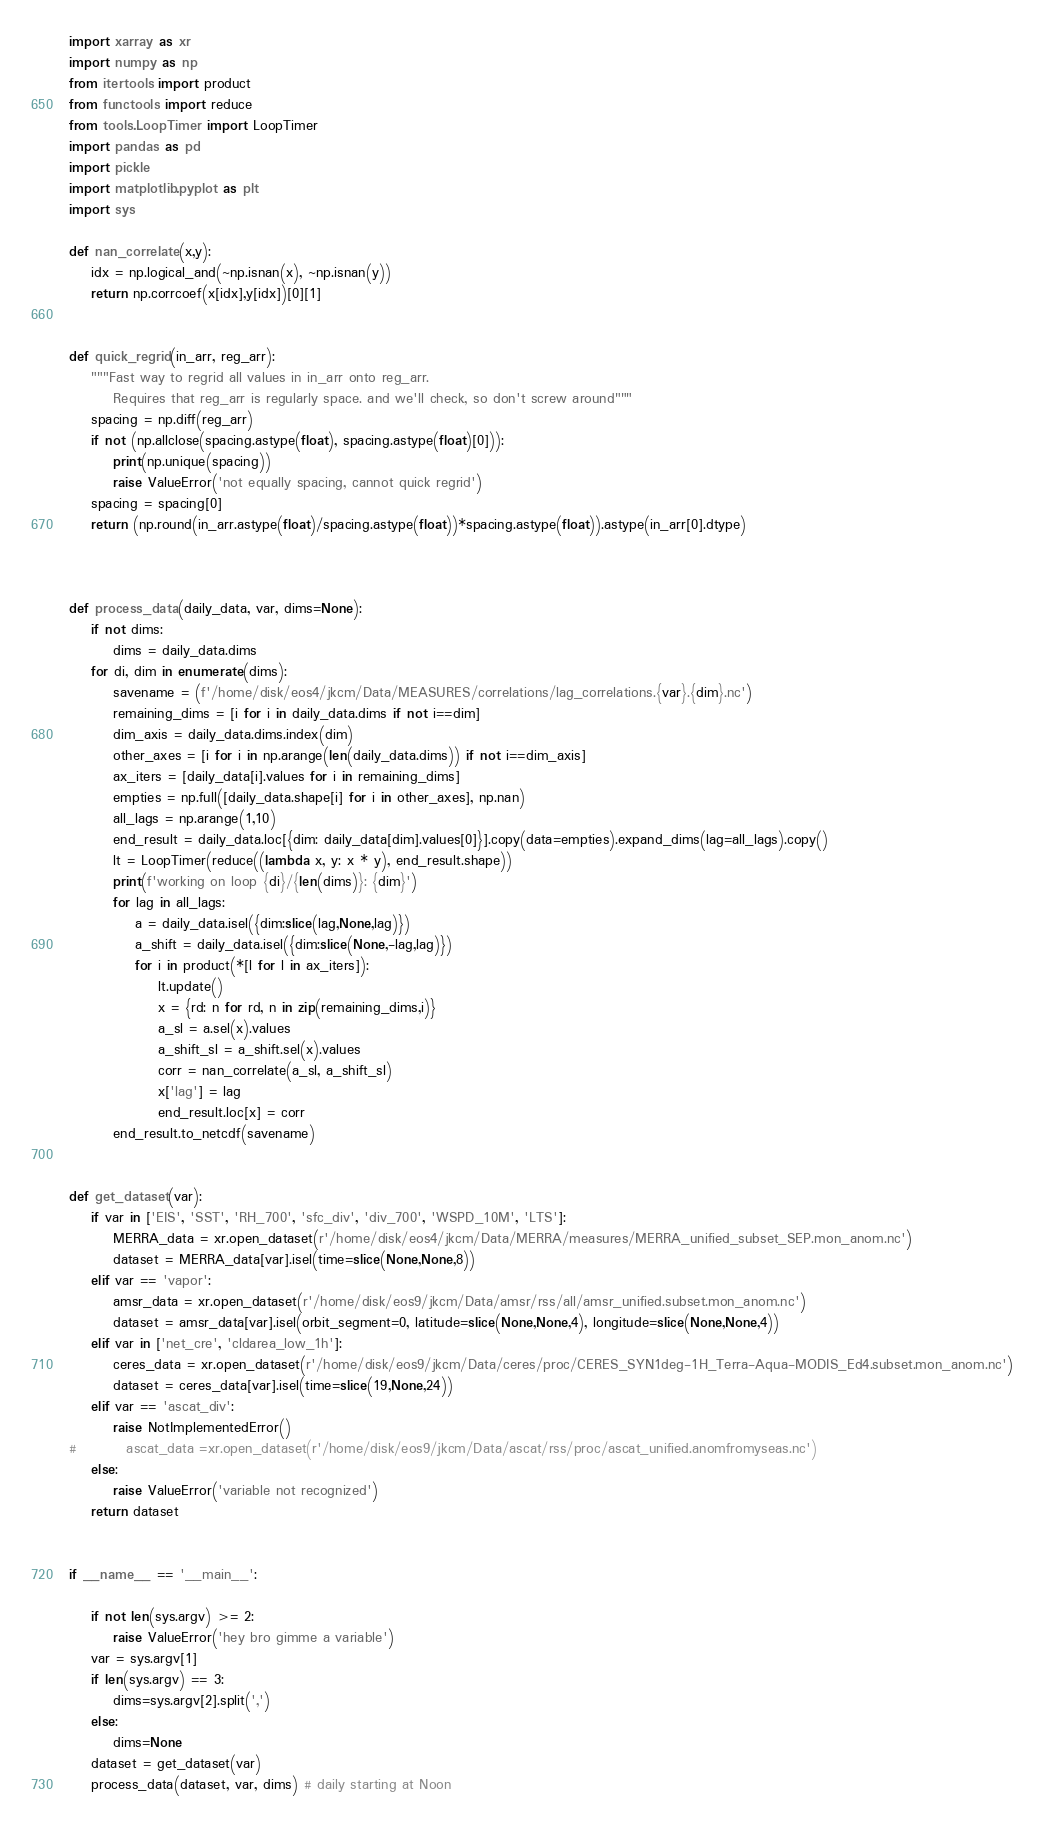<code> <loc_0><loc_0><loc_500><loc_500><_Python_>import xarray as xr
import numpy as np
from itertools import product
from functools import reduce
from tools.LoopTimer import LoopTimer
import pandas as pd
import pickle
import matplotlib.pyplot as plt
import sys

def nan_correlate(x,y):
    idx = np.logical_and(~np.isnan(x), ~np.isnan(y))
    return np.corrcoef(x[idx],y[idx])[0][1]


def quick_regrid(in_arr, reg_arr):
    """Fast way to regrid all values in in_arr onto reg_arr.
        Requires that reg_arr is regularly space. and we'll check, so don't screw around"""
    spacing = np.diff(reg_arr)
    if not (np.allclose(spacing.astype(float), spacing.astype(float)[0])):
        print(np.unique(spacing))
        raise ValueError('not equally spacing, cannot quick regrid')
    spacing = spacing[0]
    return (np.round(in_arr.astype(float)/spacing.astype(float))*spacing.astype(float)).astype(in_arr[0].dtype)
    


def process_data(daily_data, var, dims=None):
    if not dims:
        dims = daily_data.dims
    for di, dim in enumerate(dims):
        savename = (f'/home/disk/eos4/jkcm/Data/MEASURES/correlations/lag_correlations.{var}.{dim}.nc')
        remaining_dims = [i for i in daily_data.dims if not i==dim]
        dim_axis = daily_data.dims.index(dim)
        other_axes = [i for i in np.arange(len(daily_data.dims)) if not i==dim_axis]
        ax_iters = [daily_data[i].values for i in remaining_dims]
        empties = np.full([daily_data.shape[i] for i in other_axes], np.nan)
        all_lags = np.arange(1,10)
        end_result = daily_data.loc[{dim: daily_data[dim].values[0]}].copy(data=empties).expand_dims(lag=all_lags).copy()
        lt = LoopTimer(reduce((lambda x, y: x * y), end_result.shape))
        print(f'working on loop {di}/{len(dims)}: {dim}')
        for lag in all_lags:
            a = daily_data.isel({dim:slice(lag,None,lag)})
            a_shift = daily_data.isel({dim:slice(None,-lag,lag)})
            for i in product(*[l for l in ax_iters]):
                lt.update()
                x = {rd: n for rd, n in zip(remaining_dims,i)}
                a_sl = a.sel(x).values
                a_shift_sl = a_shift.sel(x).values
                corr = nan_correlate(a_sl, a_shift_sl)
                x['lag'] = lag
                end_result.loc[x] = corr
        end_result.to_netcdf(savename)
            

def get_dataset(var):
    if var in ['EIS', 'SST', 'RH_700', 'sfc_div', 'div_700', 'WSPD_10M', 'LTS']:
        MERRA_data = xr.open_dataset(r'/home/disk/eos4/jkcm/Data/MERRA/measures/MERRA_unified_subset_SEP.mon_anom.nc')
        dataset = MERRA_data[var].isel(time=slice(None,None,8))
    elif var == 'vapor':
        amsr_data = xr.open_dataset(r'/home/disk/eos9/jkcm/Data/amsr/rss/all/amsr_unified.subset.mon_anom.nc')
        dataset = amsr_data[var].isel(orbit_segment=0, latitude=slice(None,None,4), longitude=slice(None,None,4))
    elif var in ['net_cre', 'cldarea_low_1h']:
        ceres_data = xr.open_dataset(r'/home/disk/eos9/jkcm/Data/ceres/proc/CERES_SYN1deg-1H_Terra-Aqua-MODIS_Ed4.subset.mon_anom.nc')
        dataset = ceres_data[var].isel(time=slice(19,None,24))
    elif var == 'ascat_div':
        raise NotImplementedError()
#         ascat_data =xr.open_dataset(r'/home/disk/eos9/jkcm/Data/ascat/rss/proc/ascat_unified.anomfromyseas.nc')
    else:
        raise ValueError('variable not recognized')        
    return dataset
    

if __name__ == '__main__':
    
    if not len(sys.argv) >= 2:
        raise ValueError('hey bro gimme a variable')
    var = sys.argv[1]    
    if len(sys.argv) == 3:
        dims=sys.argv[2].split(',')
    else:
        dims=None
    dataset = get_dataset(var)
    process_data(dataset, var, dims) # daily starting at Noon

</code> 